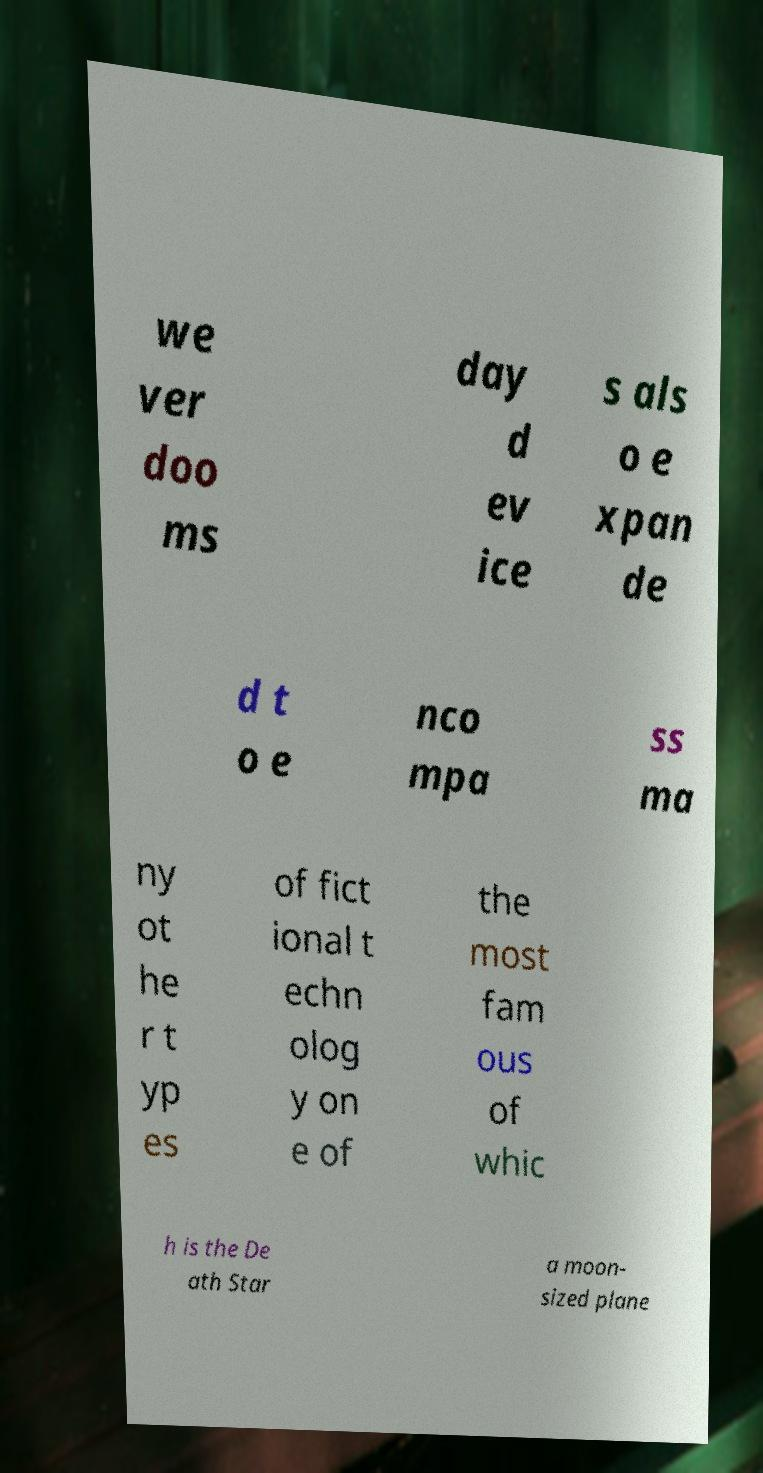What messages or text are displayed in this image? I need them in a readable, typed format. we ver doo ms day d ev ice s als o e xpan de d t o e nco mpa ss ma ny ot he r t yp es of fict ional t echn olog y on e of the most fam ous of whic h is the De ath Star a moon- sized plane 